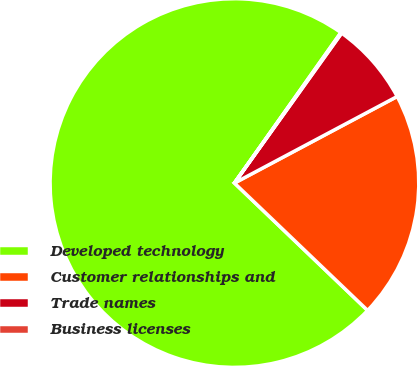Convert chart to OTSL. <chart><loc_0><loc_0><loc_500><loc_500><pie_chart><fcel>Developed technology<fcel>Customer relationships and<fcel>Trade names<fcel>Business licenses<nl><fcel>72.66%<fcel>19.93%<fcel>7.34%<fcel>0.08%<nl></chart> 